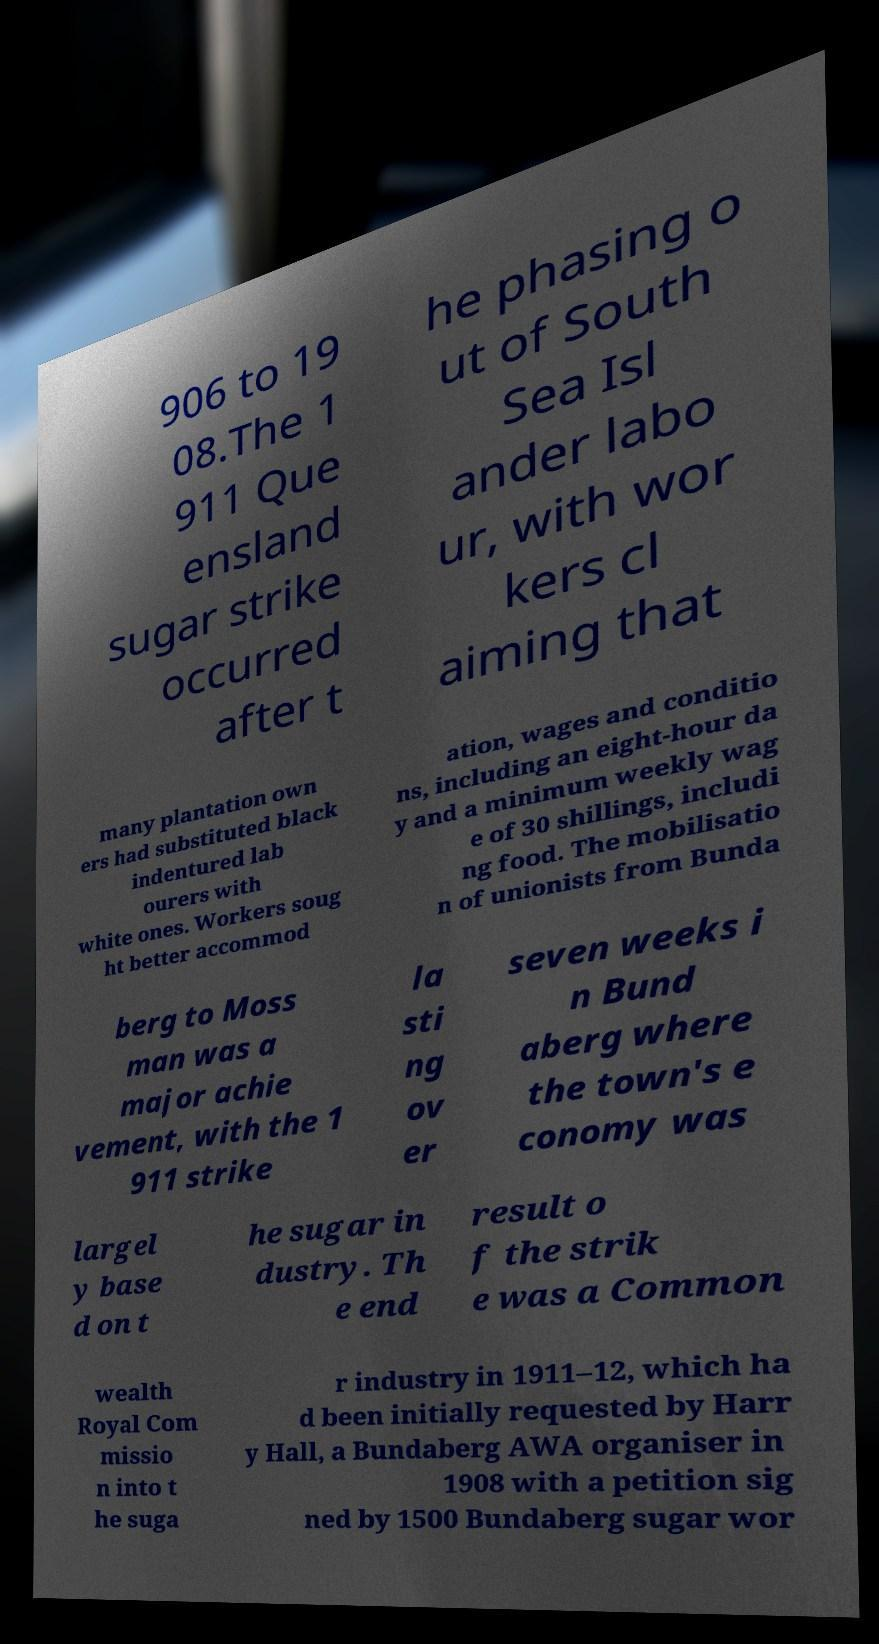Can you read and provide the text displayed in the image?This photo seems to have some interesting text. Can you extract and type it out for me? 906 to 19 08.The 1 911 Que ensland sugar strike occurred after t he phasing o ut of South Sea Isl ander labo ur, with wor kers cl aiming that many plantation own ers had substituted black indentured lab ourers with white ones. Workers soug ht better accommod ation, wages and conditio ns, including an eight-hour da y and a minimum weekly wag e of 30 shillings, includi ng food. The mobilisatio n of unionists from Bunda berg to Moss man was a major achie vement, with the 1 911 strike la sti ng ov er seven weeks i n Bund aberg where the town's e conomy was largel y base d on t he sugar in dustry. Th e end result o f the strik e was a Common wealth Royal Com missio n into t he suga r industry in 1911–12, which ha d been initially requested by Harr y Hall, a Bundaberg AWA organiser in 1908 with a petition sig ned by 1500 Bundaberg sugar wor 